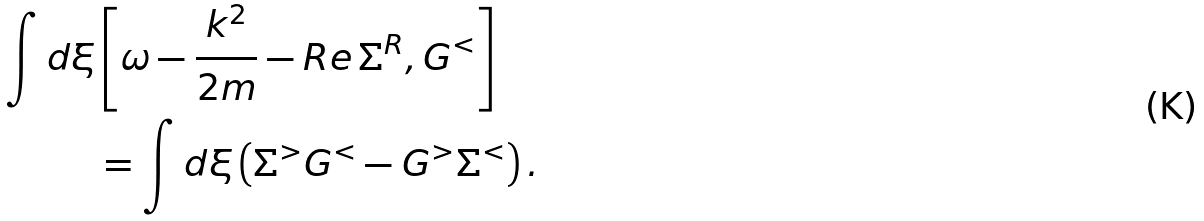Convert formula to latex. <formula><loc_0><loc_0><loc_500><loc_500>\int d \xi & \left [ \omega - \frac { k ^ { 2 } } { 2 m } - R e \, \Sigma ^ { R } , G ^ { < } \right ] \\ & = \int d \xi \left ( \Sigma ^ { > } G ^ { < } - G ^ { > } \Sigma ^ { < } \right ) .</formula> 